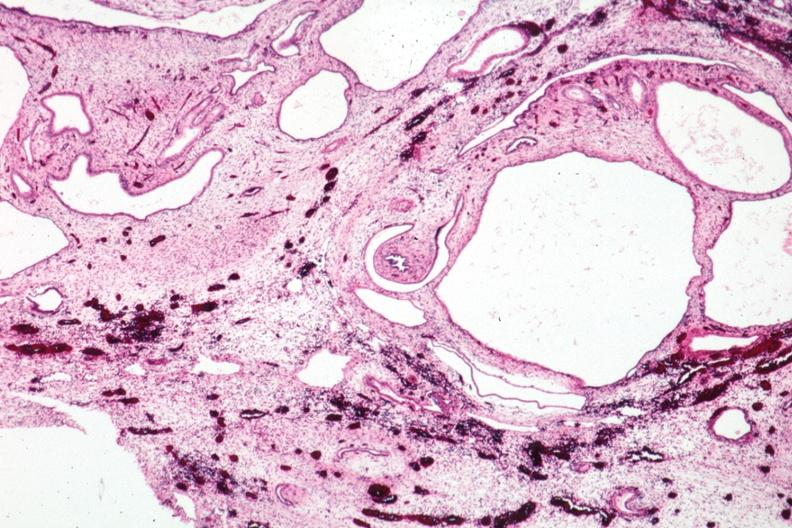what is present?
Answer the question using a single word or phrase. Polycystic disease infant 